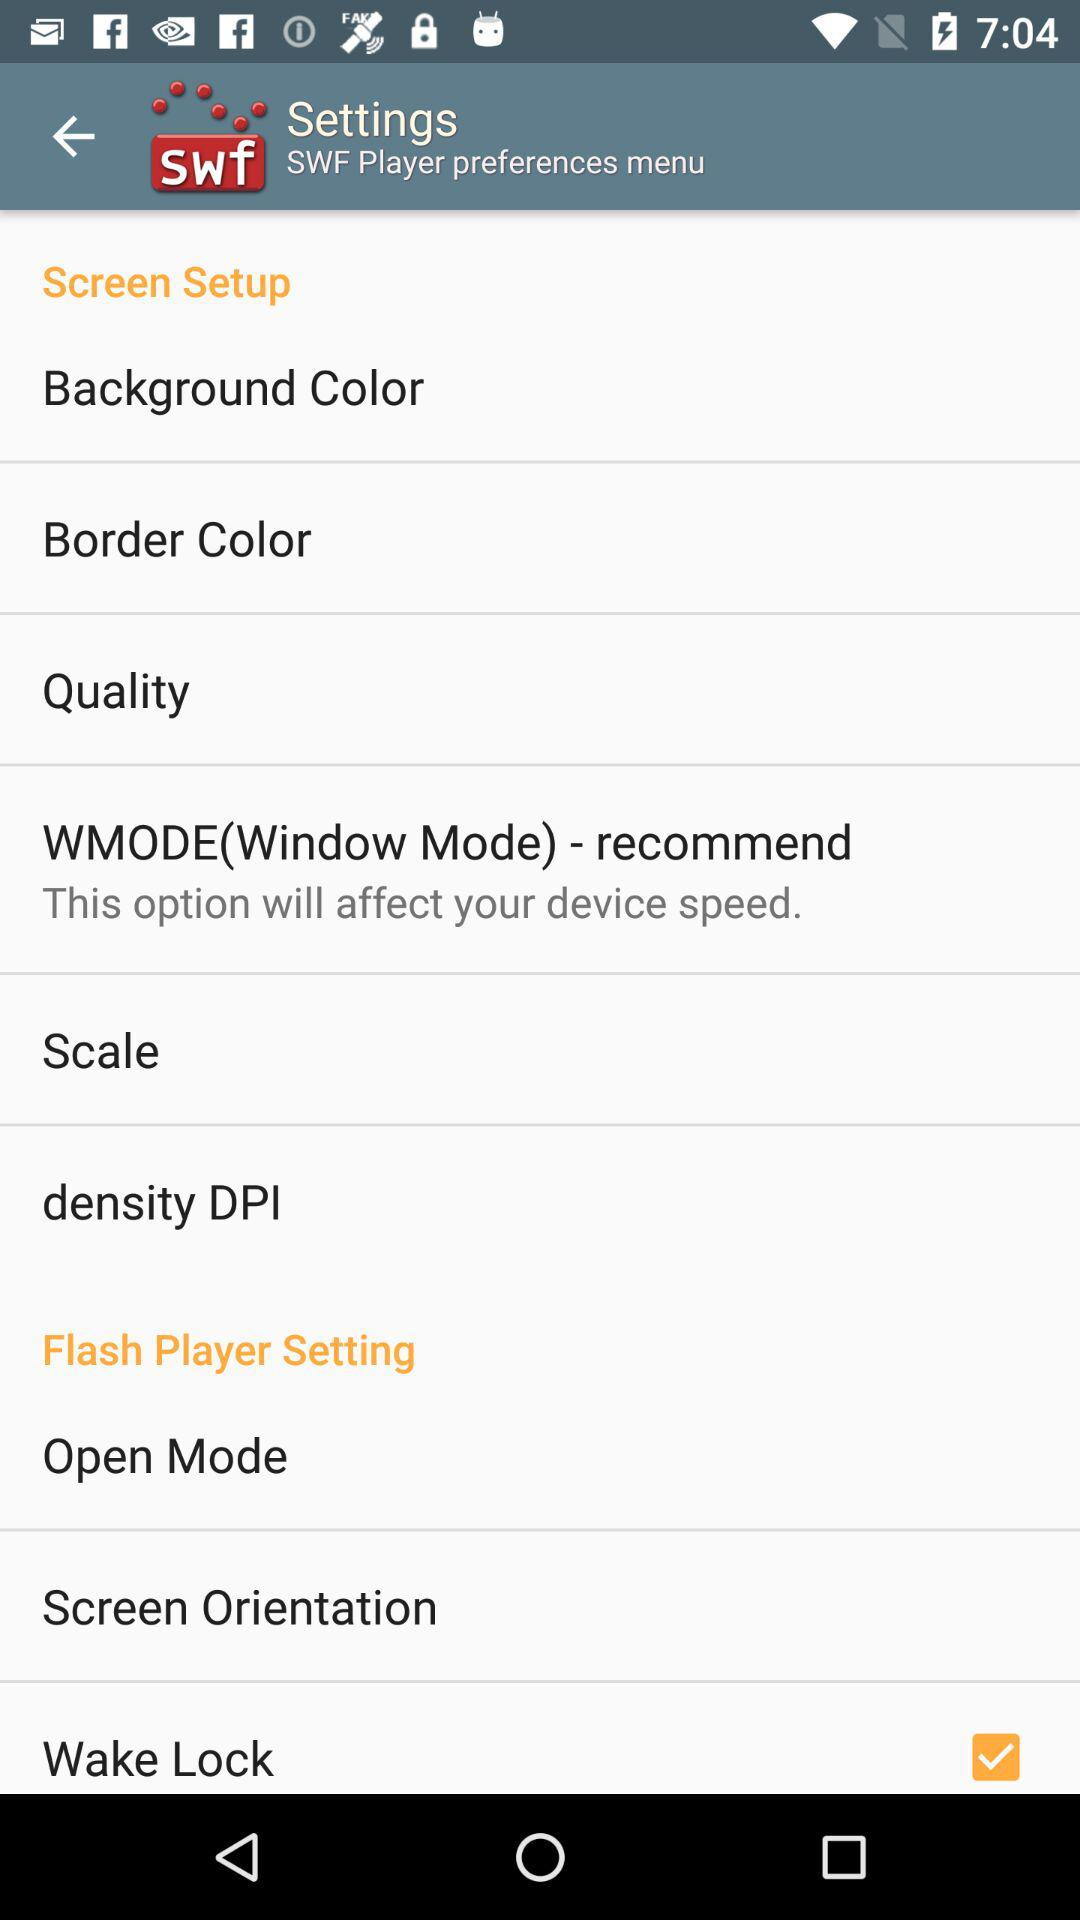What option is marked as checked? The option is "Wake Lock". 